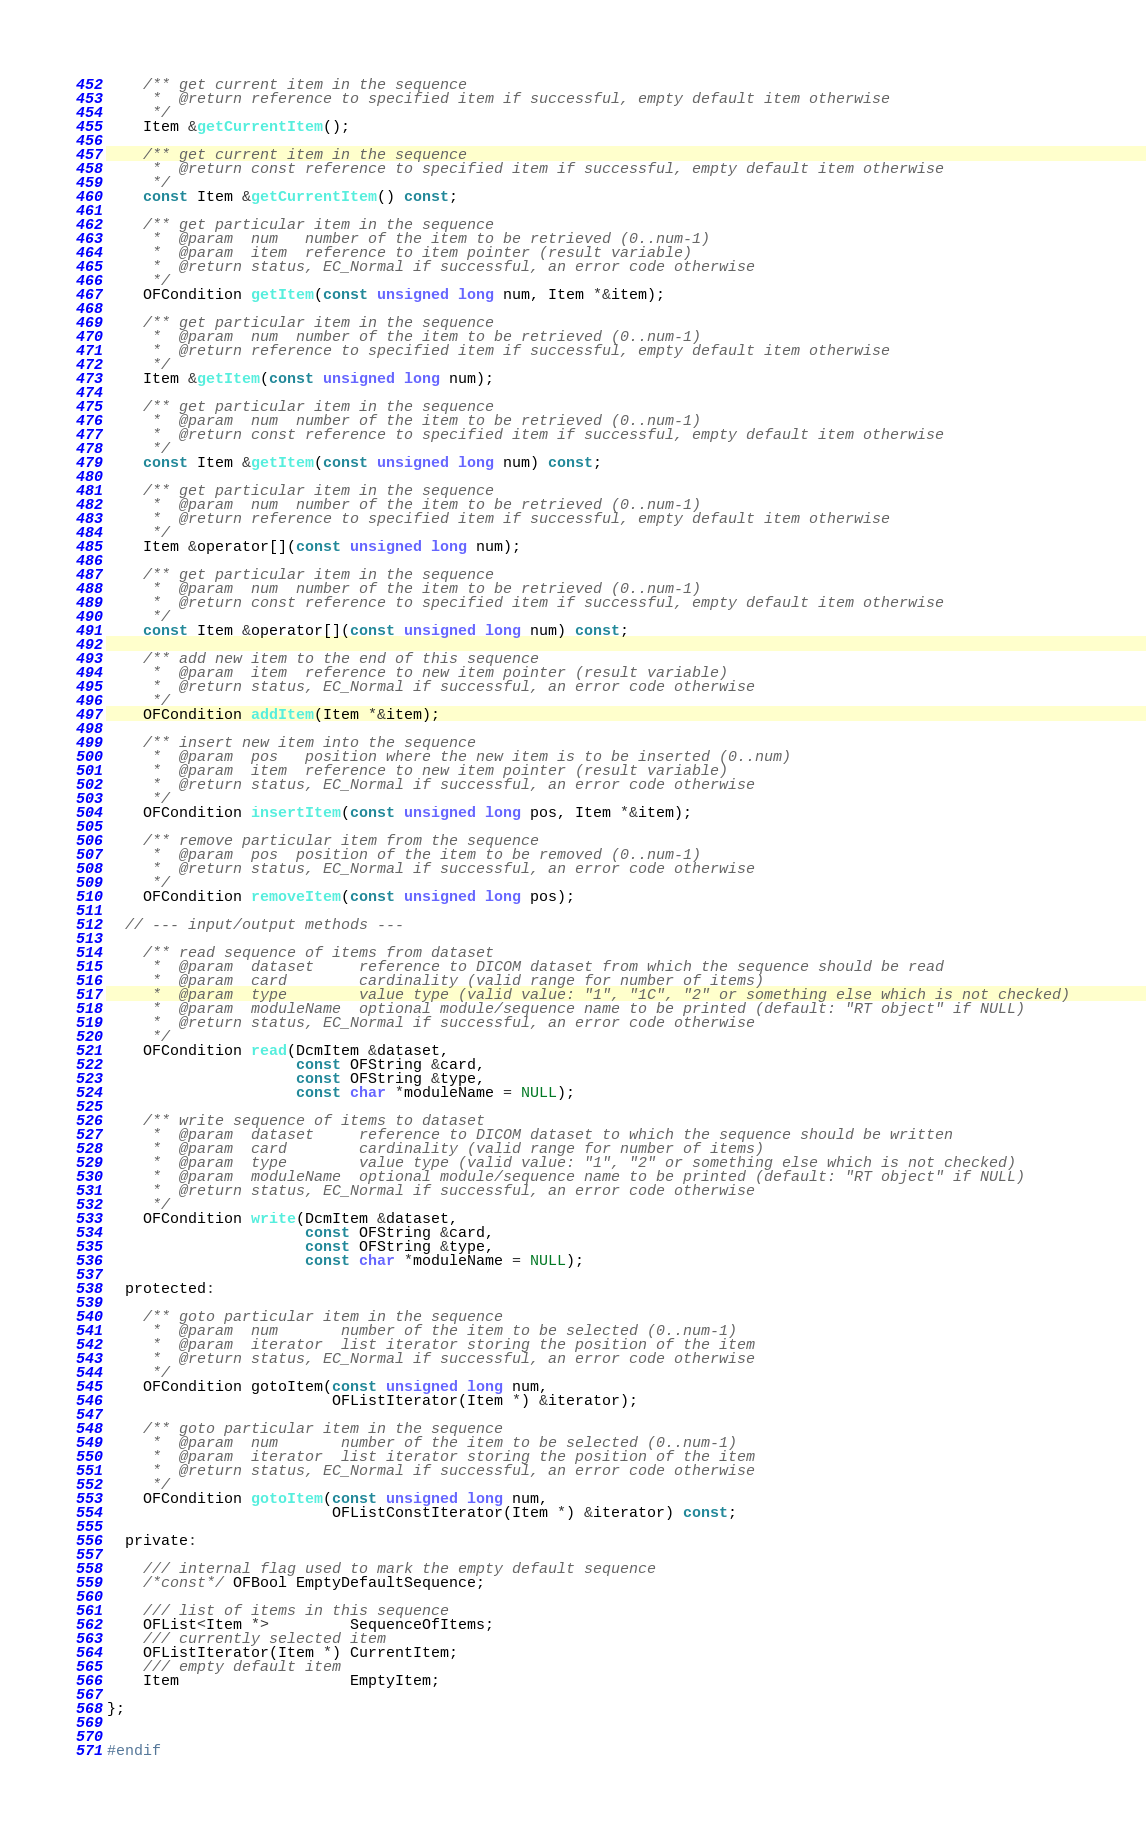Convert code to text. <code><loc_0><loc_0><loc_500><loc_500><_C_>    /** get current item in the sequence
     *  @return reference to specified item if successful, empty default item otherwise
     */
    Item &getCurrentItem();

    /** get current item in the sequence
     *  @return const reference to specified item if successful, empty default item otherwise
     */
    const Item &getCurrentItem() const;

    /** get particular item in the sequence
     *  @param  num   number of the item to be retrieved (0..num-1)
     *  @param  item  reference to item pointer (result variable)
     *  @return status, EC_Normal if successful, an error code otherwise
     */
    OFCondition getItem(const unsigned long num, Item *&item);

    /** get particular item in the sequence
     *  @param  num  number of the item to be retrieved (0..num-1)
     *  @return reference to specified item if successful, empty default item otherwise
     */
    Item &getItem(const unsigned long num);

    /** get particular item in the sequence
     *  @param  num  number of the item to be retrieved (0..num-1)
     *  @return const reference to specified item if successful, empty default item otherwise
     */
    const Item &getItem(const unsigned long num) const;

    /** get particular item in the sequence
     *  @param  num  number of the item to be retrieved (0..num-1)
     *  @return reference to specified item if successful, empty default item otherwise
     */
    Item &operator[](const unsigned long num);

    /** get particular item in the sequence
     *  @param  num  number of the item to be retrieved (0..num-1)
     *  @return const reference to specified item if successful, empty default item otherwise
     */
    const Item &operator[](const unsigned long num) const;

    /** add new item to the end of this sequence
     *  @param  item  reference to new item pointer (result variable)
     *  @return status, EC_Normal if successful, an error code otherwise
     */
    OFCondition addItem(Item *&item);

    /** insert new item into the sequence
     *  @param  pos   position where the new item is to be inserted (0..num)
     *  @param  item  reference to new item pointer (result variable)
     *  @return status, EC_Normal if successful, an error code otherwise
     */
    OFCondition insertItem(const unsigned long pos, Item *&item);

    /** remove particular item from the sequence
     *  @param  pos  position of the item to be removed (0..num-1)
     *  @return status, EC_Normal if successful, an error code otherwise
     */
    OFCondition removeItem(const unsigned long pos);

  // --- input/output methods ---

    /** read sequence of items from dataset
     *  @param  dataset     reference to DICOM dataset from which the sequence should be read
     *  @param  card        cardinality (valid range for number of items)
     *  @param  type        value type (valid value: "1", "1C", "2" or something else which is not checked)
     *  @param  moduleName  optional module/sequence name to be printed (default: "RT object" if NULL)
     *  @return status, EC_Normal if successful, an error code otherwise
     */
    OFCondition read(DcmItem &dataset,
                     const OFString &card,
                     const OFString &type,
                     const char *moduleName = NULL);

    /** write sequence of items to dataset
     *  @param  dataset     reference to DICOM dataset to which the sequence should be written
     *  @param  card        cardinality (valid range for number of items)
     *  @param  type        value type (valid value: "1", "2" or something else which is not checked)
     *  @param  moduleName  optional module/sequence name to be printed (default: "RT object" if NULL)
     *  @return status, EC_Normal if successful, an error code otherwise
     */
    OFCondition write(DcmItem &dataset,
                      const OFString &card,
                      const OFString &type,
                      const char *moduleName = NULL);

  protected:

    /** goto particular item in the sequence
     *  @param  num       number of the item to be selected (0..num-1)
     *  @param  iterator  list iterator storing the position of the item
     *  @return status, EC_Normal if successful, an error code otherwise
     */
    OFCondition gotoItem(const unsigned long num,
                         OFListIterator(Item *) &iterator);

    /** goto particular item in the sequence
     *  @param  num       number of the item to be selected (0..num-1)
     *  @param  iterator  list iterator storing the position of the item
     *  @return status, EC_Normal if successful, an error code otherwise
     */
    OFCondition gotoItem(const unsigned long num,
                         OFListConstIterator(Item *) &iterator) const;

  private:

    /// internal flag used to mark the empty default sequence
    /*const*/ OFBool EmptyDefaultSequence;

    /// list of items in this sequence
    OFList<Item *>         SequenceOfItems;
    /// currently selected item
    OFListIterator(Item *) CurrentItem;
    /// empty default item
    Item                   EmptyItem;

};


#endif
</code> 